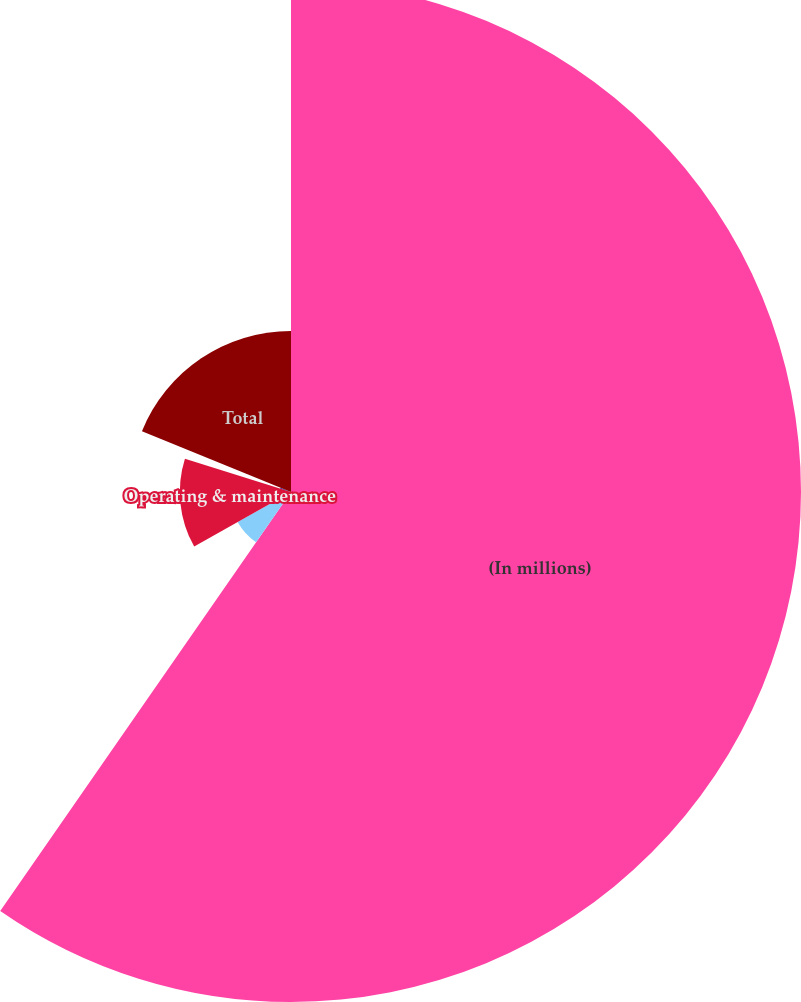<chart> <loc_0><loc_0><loc_500><loc_500><pie_chart><fcel>(In millions)<fcel>Capital<fcel>Operating & maintenance<fcel>Remediation (b)<fcel>Total<nl><fcel>59.65%<fcel>7.17%<fcel>13.0%<fcel>1.34%<fcel>18.83%<nl></chart> 